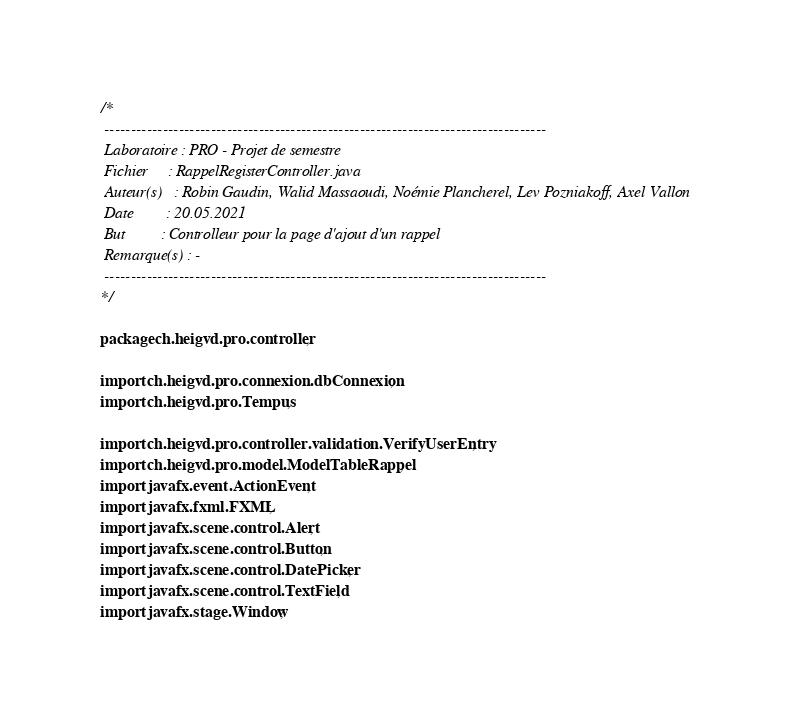Convert code to text. <code><loc_0><loc_0><loc_500><loc_500><_Java_>/*
 -----------------------------------------------------------------------------------
 Laboratoire : PRO - Projet de semestre
 Fichier     : RappelRegisterController.java
 Auteur(s)   : Robin Gaudin, Walid Massaoudi, Noémie Plancherel, Lev Pozniakoff, Axel Vallon
 Date        : 20.05.2021
 But         : Controlleur pour la page d'ajout d'un rappel
 Remarque(s) : -
 -----------------------------------------------------------------------------------
*/

package ch.heigvd.pro.controller;

import ch.heigvd.pro.connexion.dbConnexion;
import ch.heigvd.pro.Tempus;

import ch.heigvd.pro.controller.validation.VerifyUserEntry;
import ch.heigvd.pro.model.ModelTableRappel;
import javafx.event.ActionEvent;
import javafx.fxml.FXML;
import javafx.scene.control.Alert;
import javafx.scene.control.Button;
import javafx.scene.control.DatePicker;
import javafx.scene.control.TextField;
import javafx.stage.Window;</code> 